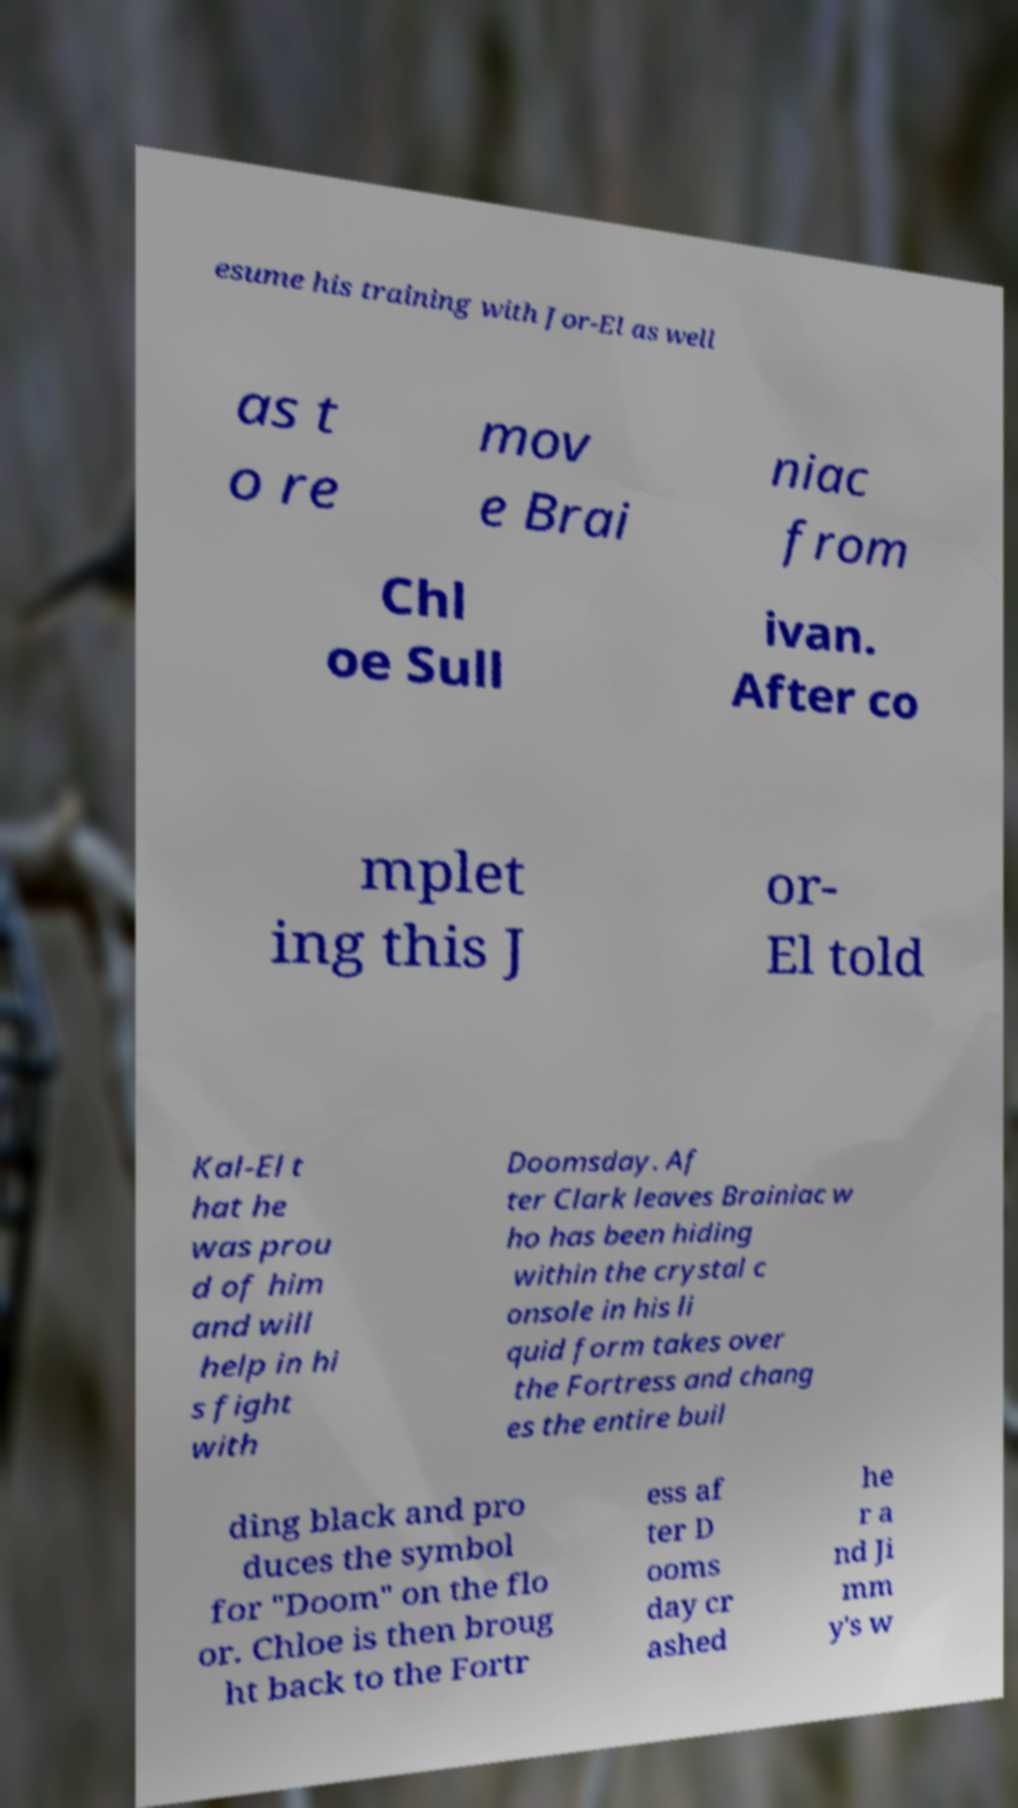Can you accurately transcribe the text from the provided image for me? esume his training with Jor-El as well as t o re mov e Brai niac from Chl oe Sull ivan. After co mplet ing this J or- El told Kal-El t hat he was prou d of him and will help in hi s fight with Doomsday. Af ter Clark leaves Brainiac w ho has been hiding within the crystal c onsole in his li quid form takes over the Fortress and chang es the entire buil ding black and pro duces the symbol for "Doom" on the flo or. Chloe is then broug ht back to the Fortr ess af ter D ooms day cr ashed he r a nd Ji mm y's w 